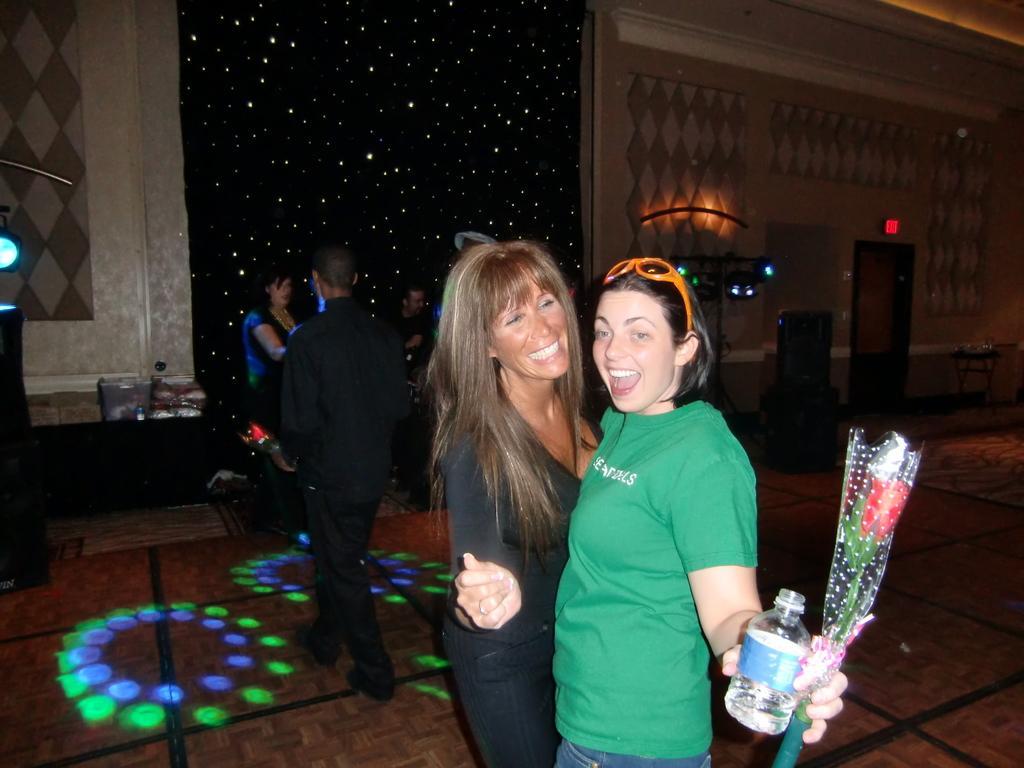Could you give a brief overview of what you see in this image? As we can see in the image there are few people here and there, wall, lights, bottle and bouquet. 